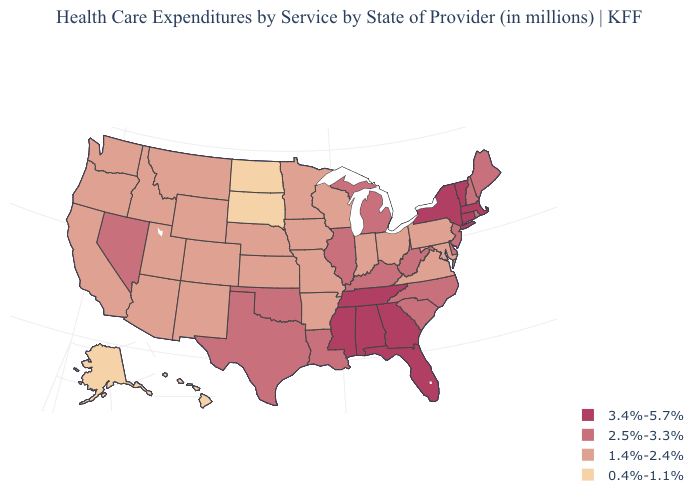Is the legend a continuous bar?
Answer briefly. No. What is the value of South Dakota?
Be succinct. 0.4%-1.1%. Does Oklahoma have the same value as North Carolina?
Give a very brief answer. Yes. What is the highest value in the West ?
Quick response, please. 2.5%-3.3%. Name the states that have a value in the range 3.4%-5.7%?
Answer briefly. Alabama, Connecticut, Florida, Georgia, Massachusetts, Mississippi, New York, Tennessee, Vermont. Does Illinois have a higher value than Maine?
Give a very brief answer. No. What is the value of Illinois?
Be succinct. 2.5%-3.3%. Among the states that border Maryland , does Virginia have the highest value?
Give a very brief answer. No. Among the states that border Oklahoma , which have the highest value?
Answer briefly. Texas. Which states hav the highest value in the Northeast?
Short answer required. Connecticut, Massachusetts, New York, Vermont. What is the value of Missouri?
Answer briefly. 1.4%-2.4%. Name the states that have a value in the range 3.4%-5.7%?
Concise answer only. Alabama, Connecticut, Florida, Georgia, Massachusetts, Mississippi, New York, Tennessee, Vermont. What is the value of North Carolina?
Be succinct. 2.5%-3.3%. Which states have the highest value in the USA?
Answer briefly. Alabama, Connecticut, Florida, Georgia, Massachusetts, Mississippi, New York, Tennessee, Vermont. Which states have the highest value in the USA?
Answer briefly. Alabama, Connecticut, Florida, Georgia, Massachusetts, Mississippi, New York, Tennessee, Vermont. 